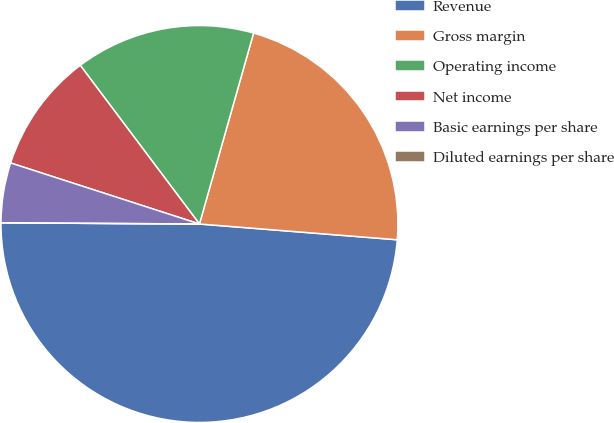<chart> <loc_0><loc_0><loc_500><loc_500><pie_chart><fcel>Revenue<fcel>Gross margin<fcel>Operating income<fcel>Net income<fcel>Basic earnings per share<fcel>Diluted earnings per share<nl><fcel>48.83%<fcel>21.87%<fcel>14.65%<fcel>9.77%<fcel>4.88%<fcel>0.0%<nl></chart> 